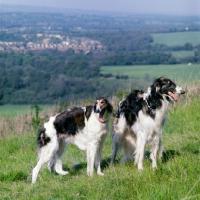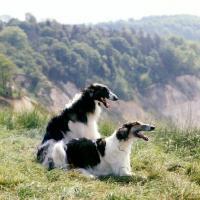The first image is the image on the left, the second image is the image on the right. For the images displayed, is the sentence "A long-haired dog with a thin face is standing with no other dogs." factually correct? Answer yes or no. No. 